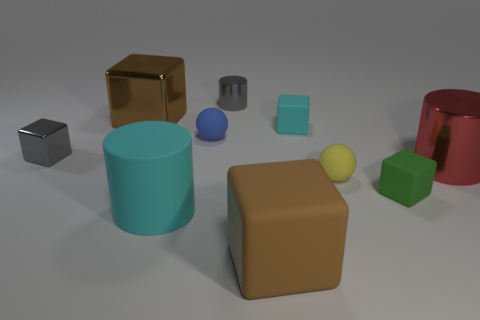How many metal things are the same color as the big matte block?
Provide a short and direct response. 1. Is the shape of the green rubber thing the same as the brown matte object?
Your response must be concise. Yes. Are there the same number of brown objects behind the brown rubber cube and gray shiny cylinders?
Provide a short and direct response. Yes. The large cyan rubber thing has what shape?
Give a very brief answer. Cylinder. Are there any other things that are the same color as the small shiny cube?
Provide a succinct answer. Yes. Is the size of the brown thing that is behind the tiny green rubber object the same as the matte object on the right side of the small yellow matte ball?
Your answer should be very brief. No. There is a cyan thing in front of the small matte block behind the tiny green object; what shape is it?
Make the answer very short. Cylinder. Does the red metallic cylinder have the same size as the cyan thing on the left side of the tiny cyan cube?
Keep it short and to the point. Yes. There is a brown thing to the right of the big cyan thing that is to the left of the tiny metallic object right of the big cyan thing; what is its size?
Make the answer very short. Large. How many objects are metallic objects to the right of the yellow sphere or big spheres?
Make the answer very short. 1. 